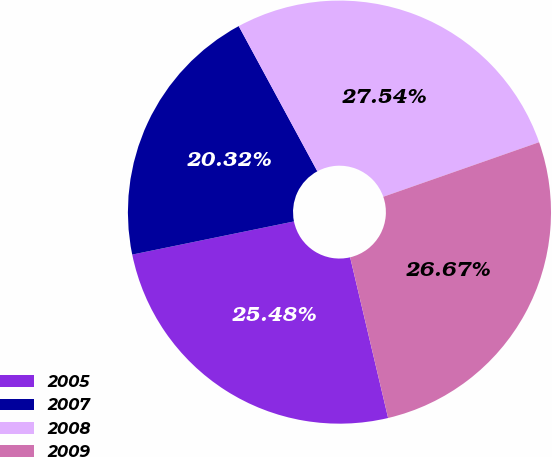Convert chart. <chart><loc_0><loc_0><loc_500><loc_500><pie_chart><fcel>2005<fcel>2007<fcel>2008<fcel>2009<nl><fcel>25.48%<fcel>20.32%<fcel>27.54%<fcel>26.67%<nl></chart> 